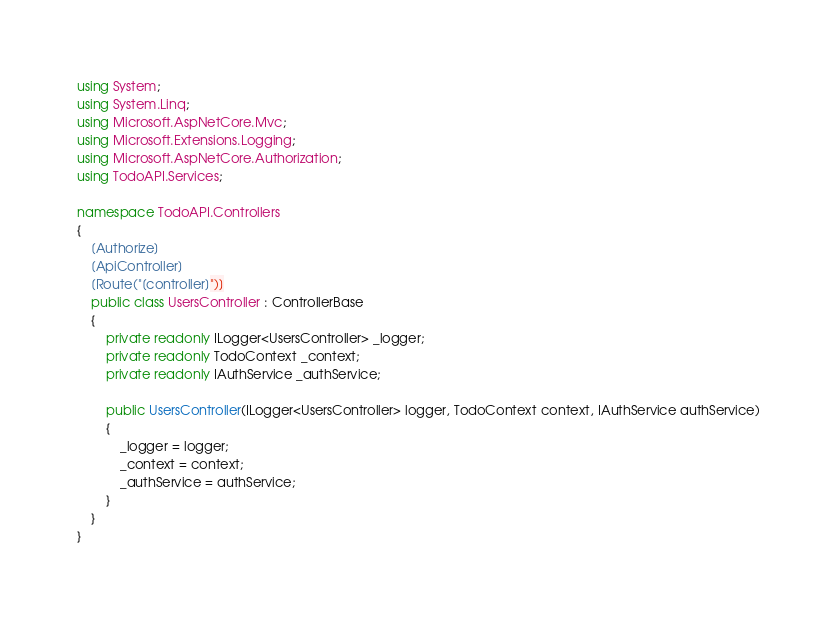Convert code to text. <code><loc_0><loc_0><loc_500><loc_500><_C#_>using System;
using System.Linq;
using Microsoft.AspNetCore.Mvc;
using Microsoft.Extensions.Logging;
using Microsoft.AspNetCore.Authorization;
using TodoAPI.Services;

namespace TodoAPI.Controllers
{
    [Authorize]
    [ApiController]
    [Route("[controller]")]
    public class UsersController : ControllerBase
    {
        private readonly ILogger<UsersController> _logger;
        private readonly TodoContext _context;
        private readonly IAuthService _authService;

        public UsersController(ILogger<UsersController> logger, TodoContext context, IAuthService authService)
        {
            _logger = logger;
            _context = context;
            _authService = authService;
        }
    }
}
</code> 